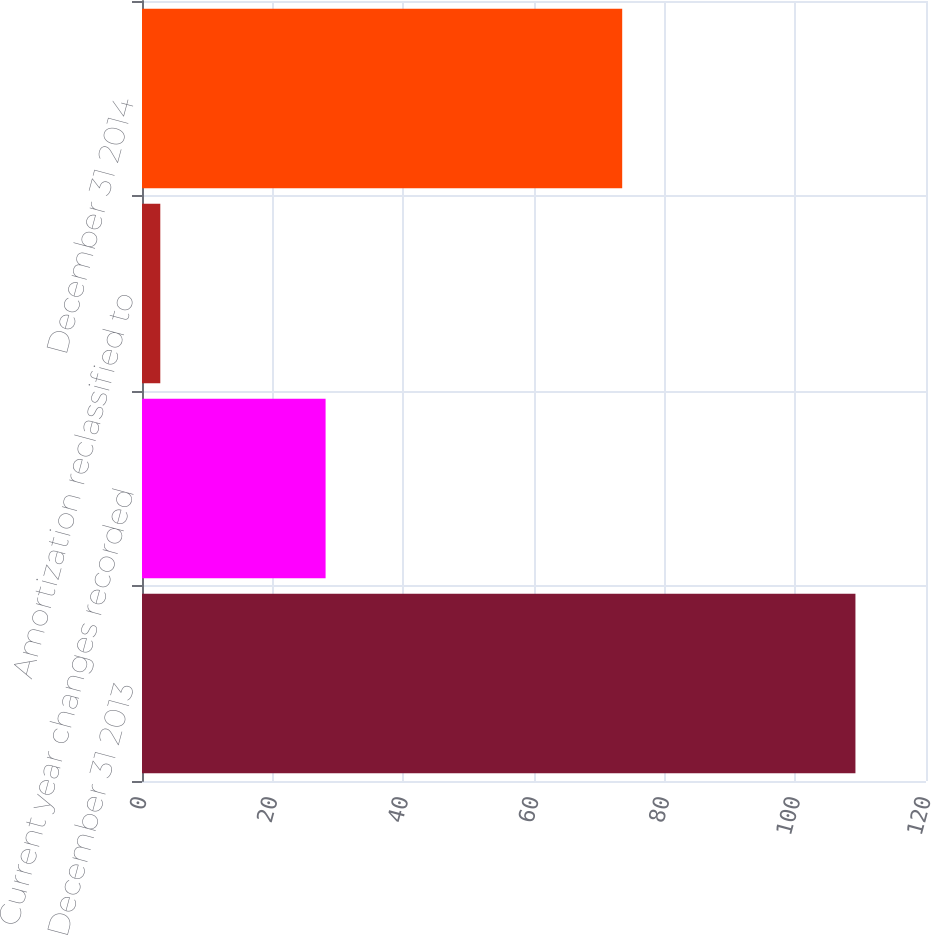<chart> <loc_0><loc_0><loc_500><loc_500><bar_chart><fcel>December 31 2013<fcel>Current year changes recorded<fcel>Amortization reclassified to<fcel>December 31 2014<nl><fcel>109.2<fcel>28.1<fcel>2.8<fcel>73.5<nl></chart> 